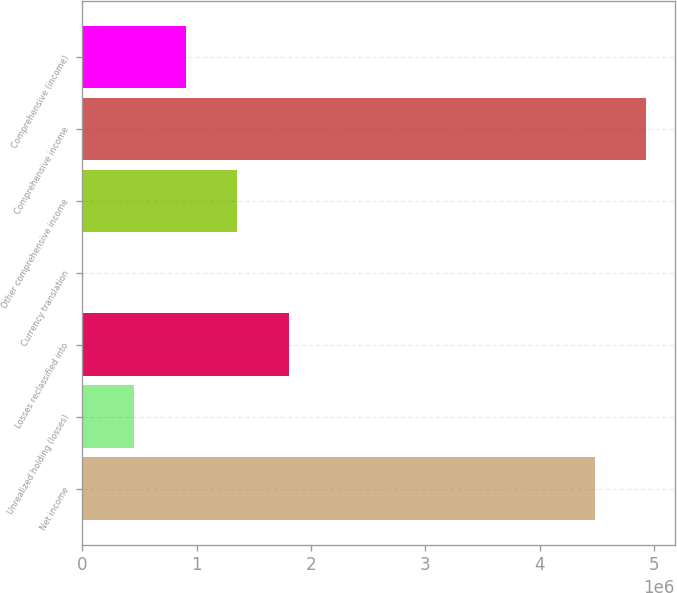Convert chart. <chart><loc_0><loc_0><loc_500><loc_500><bar_chart><fcel>Net income<fcel>Unrealized holding (losses)<fcel>Losses reclassified into<fcel>Currency translation<fcel>Other comprehensive income<fcel>Comprehensive income<fcel>Comprehensive (income)<nl><fcel>4.4801e+06<fcel>452059<fcel>1.80744e+06<fcel>264<fcel>1.35565e+06<fcel>4.9319e+06<fcel>903853<nl></chart> 